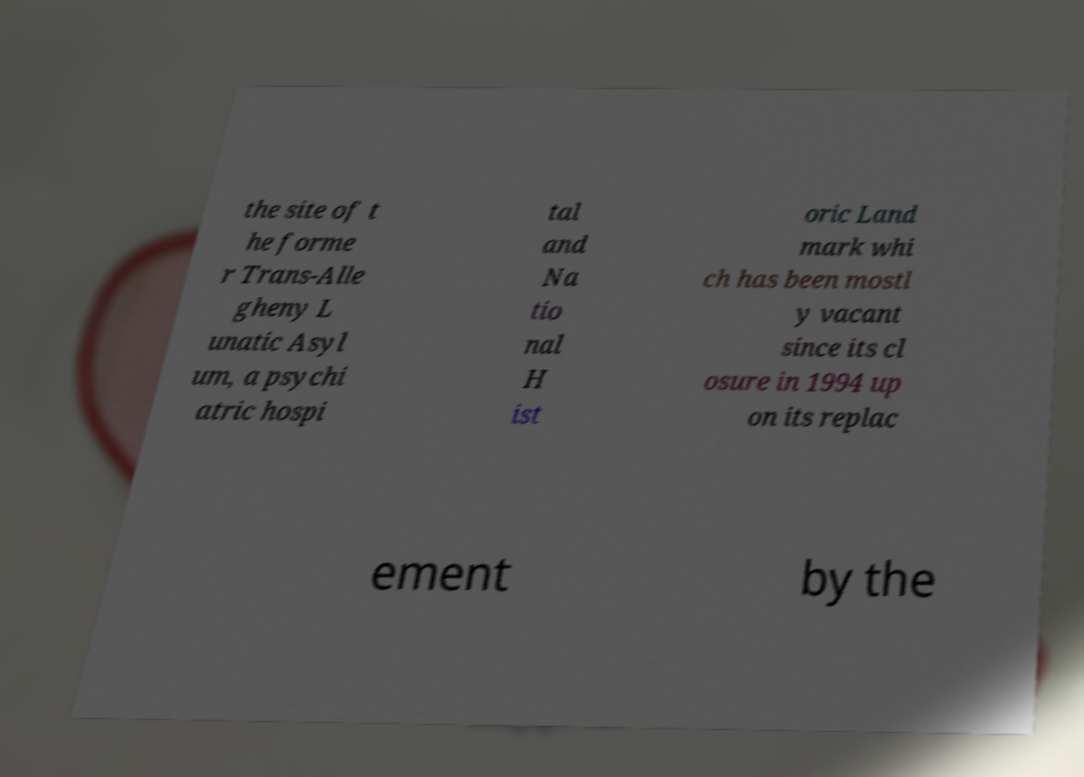Could you assist in decoding the text presented in this image and type it out clearly? the site of t he forme r Trans-Alle gheny L unatic Asyl um, a psychi atric hospi tal and Na tio nal H ist oric Land mark whi ch has been mostl y vacant since its cl osure in 1994 up on its replac ement by the 